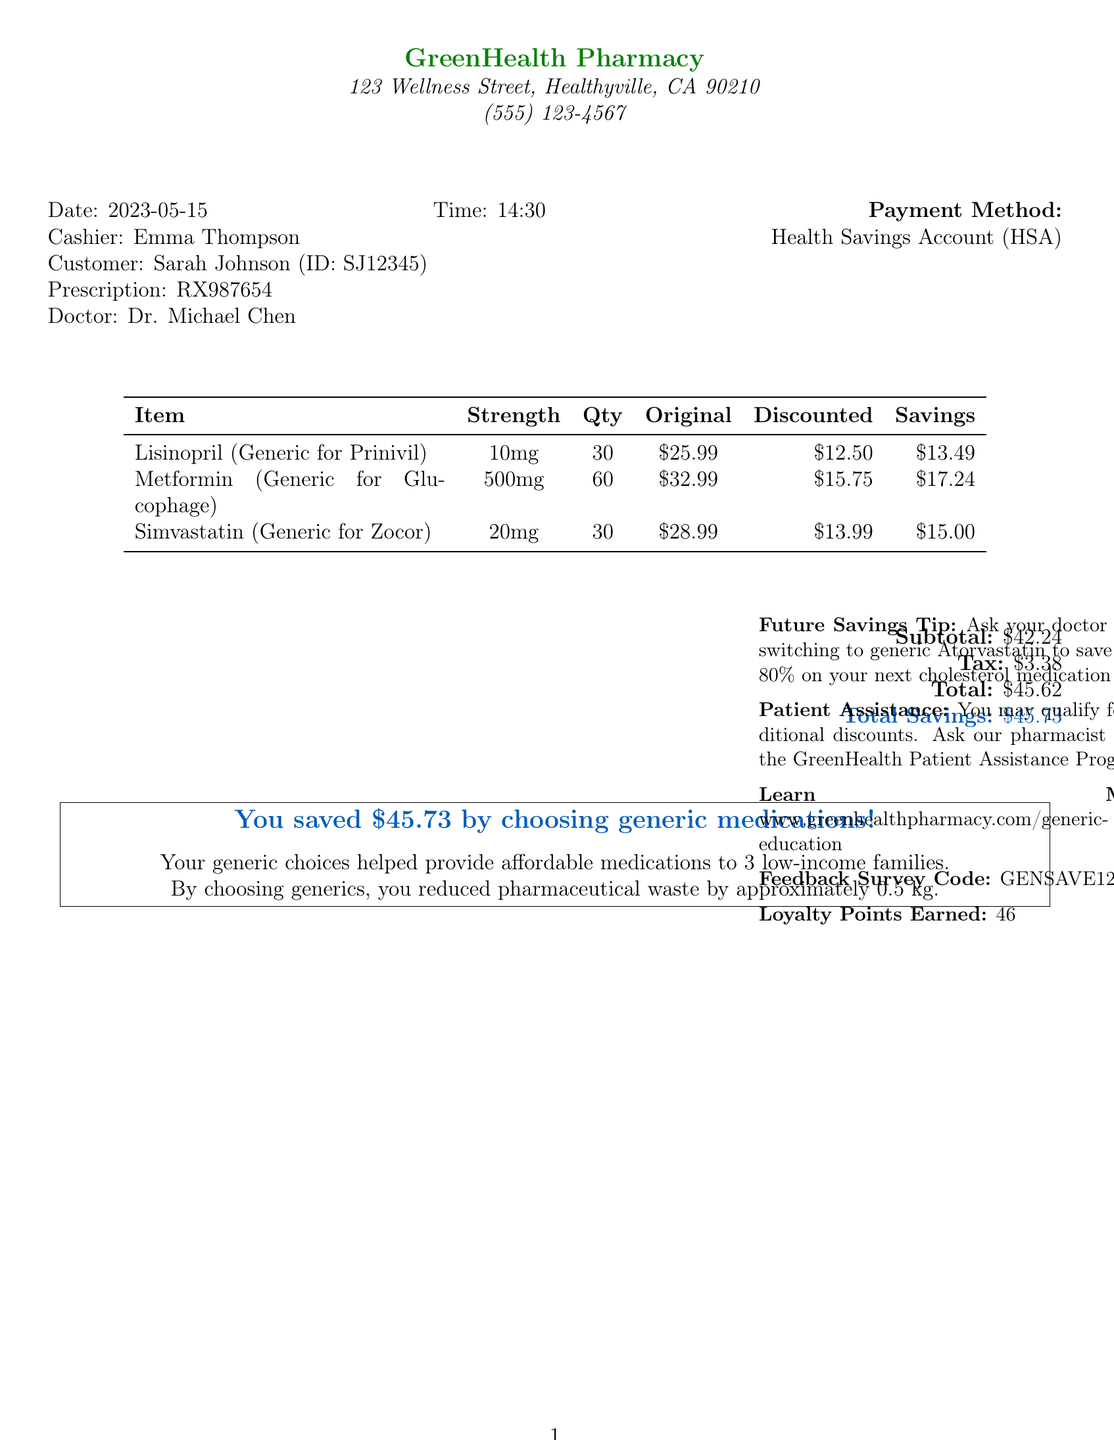What is the pharmacy name? The pharmacy name is listed at the top of the receipt, which is GreenHealth Pharmacy.
Answer: GreenHealth Pharmacy What is the total discounted savings? The total savings is mentioned in the receipt, which is the amount saved by choosing generic medications.
Answer: $45.73 How many loyalty points were earned? The number of loyalty points earned is stated in the document under the payment details.
Answer: 46 What is the strength of Metformin? The strength of Metformin is provided in the itemized list on the receipt for that medication.
Answer: 500mg Who is the prescribing doctor? The prescribing doctor is mentioned in the customer details section of the receipt.
Answer: Dr. Michael Chen What is the original price of Simvastatin? The original price for Simvastatin is listed in the itemized medications table in the document.
Answer: $28.99 How many low-income families benefited from the purchase? The document states how many families were helped, based on the generic choices made.
Answer: 3 low-income families What was the total amount charged? The total amount charged is the final total in the payment summary of the document.
Answer: $45.62 What tip is given for future savings? The future savings tip is provided at the bottom of the receipt to encourage savings on future prescriptions.
Answer: Ask your doctor about switching to generic Atorvastatin to save up to 80% on your next cholesterol medication refill 